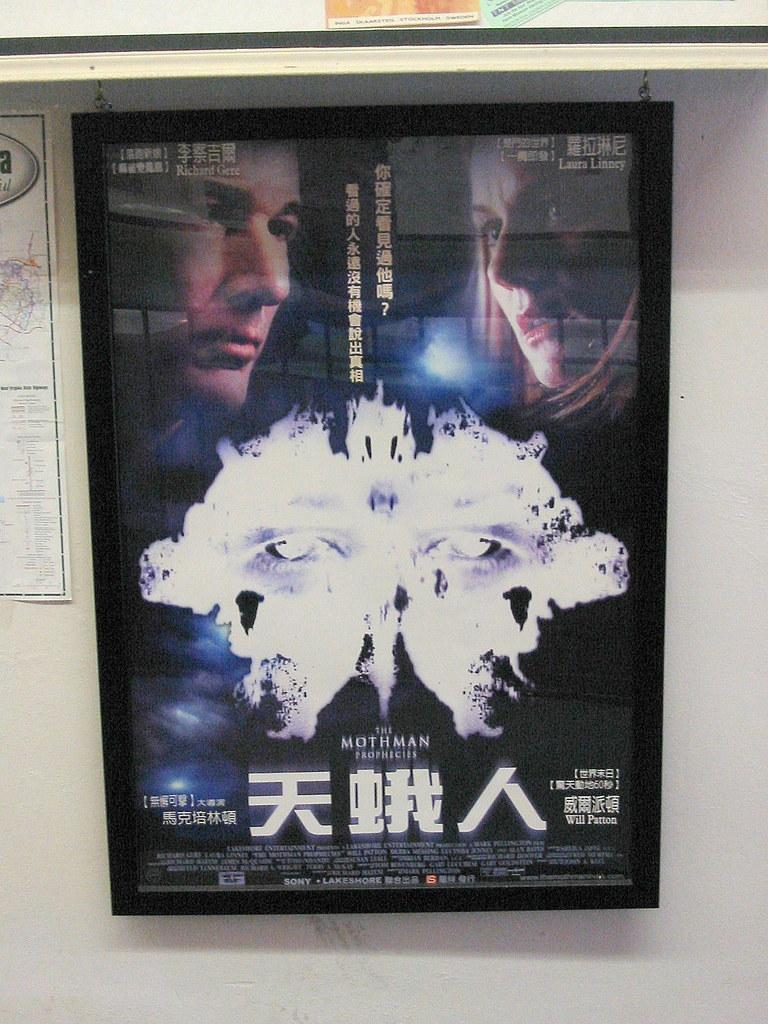Provide a one-sentence caption for the provided image. A movie in Chinese called The Mothman Prophecies. 